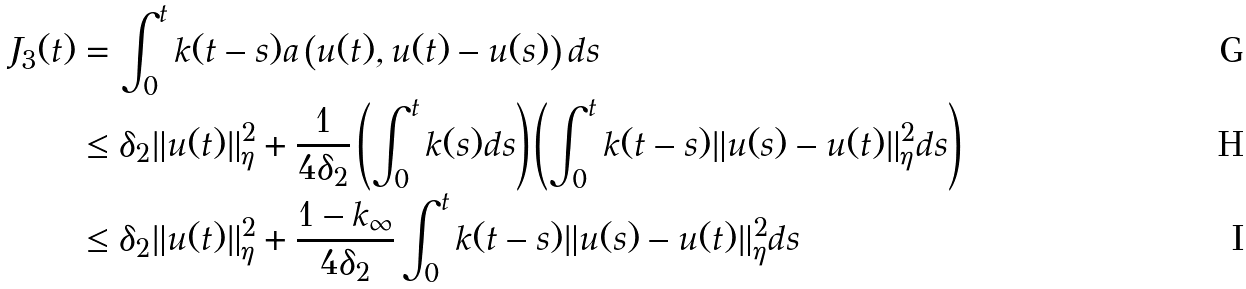<formula> <loc_0><loc_0><loc_500><loc_500>J _ { 3 } ( t ) & = \int _ { 0 } ^ { t } k ( t - s ) a \left ( u ( t ) , u ( t ) - u ( s ) \right ) d s \\ & \leq \delta _ { 2 } \| u ( t ) \| _ { \eta } ^ { 2 } + \frac { 1 } { 4 \delta _ { 2 } } \left ( \int _ { 0 } ^ { t } k ( s ) d s \right ) \left ( \int _ { 0 } ^ { t } k ( t - s ) \| u ( s ) - u ( t ) \| _ { \eta } ^ { 2 } d s \right ) \\ & \leq \delta _ { 2 } \| u ( t ) \| _ { \eta } ^ { 2 } + \frac { 1 - k _ { \infty } } { 4 \delta _ { 2 } } \int _ { 0 } ^ { t } k ( t - s ) \| u ( s ) - u ( t ) \| _ { \eta } ^ { 2 } d s</formula> 